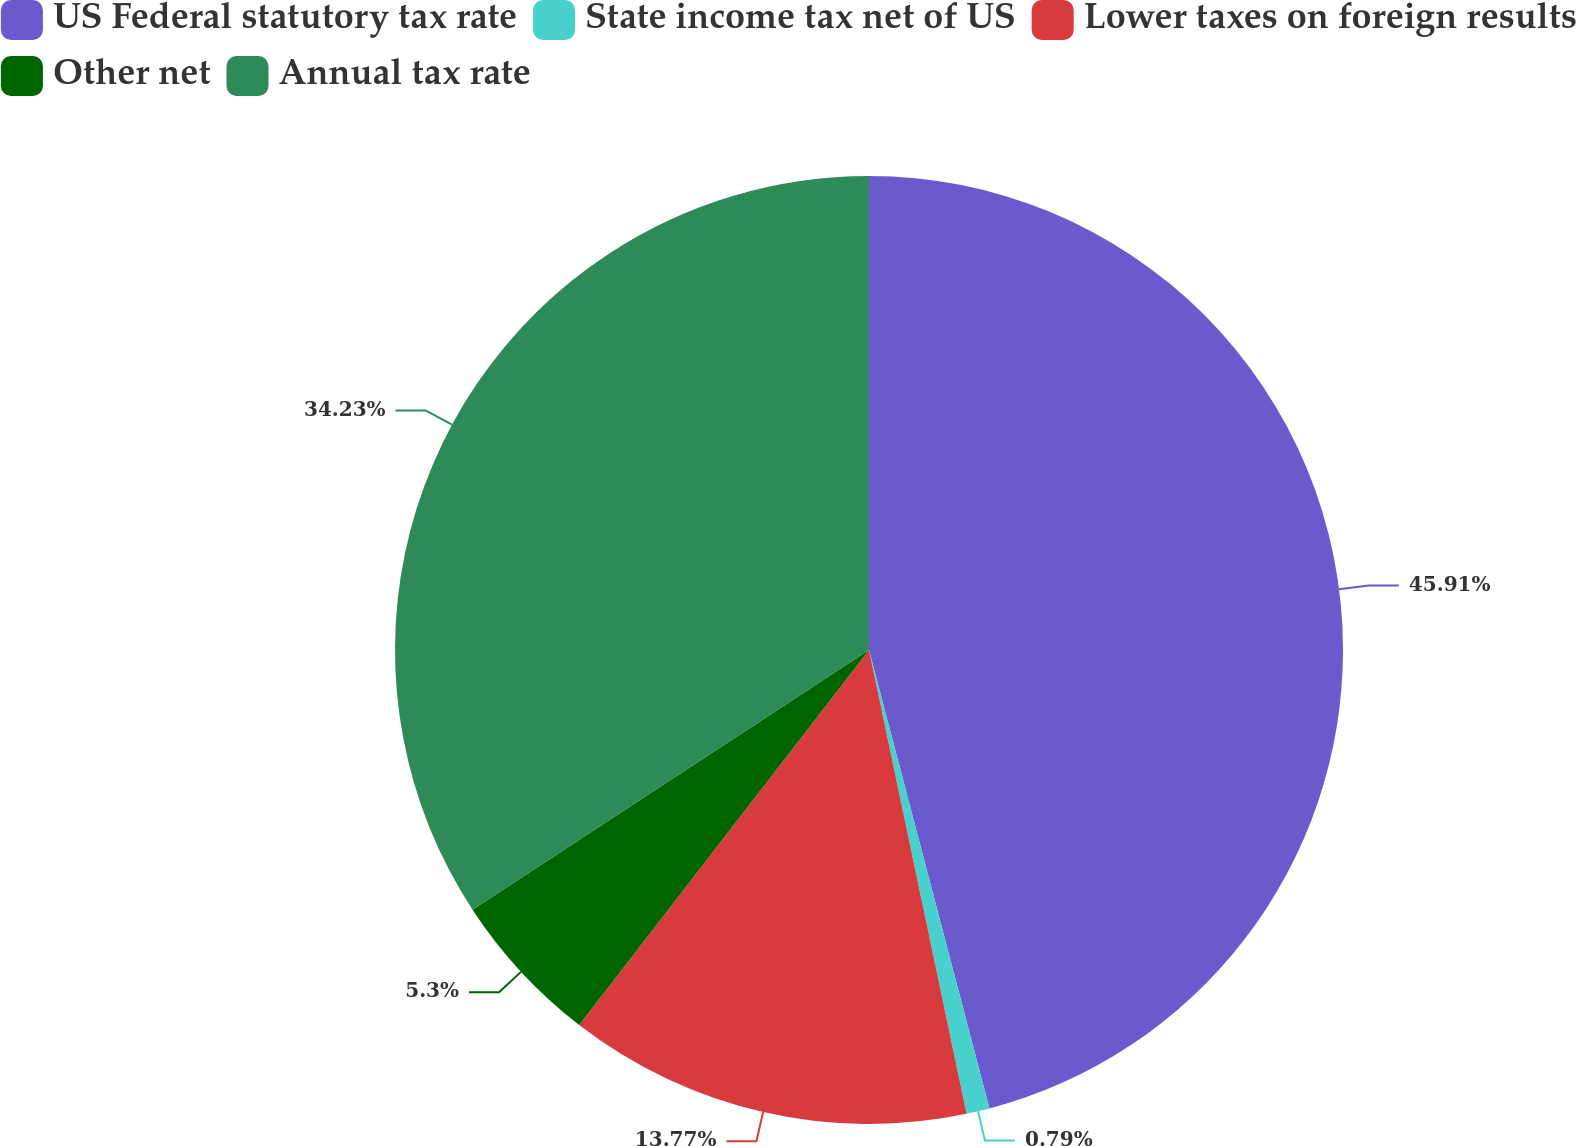Convert chart to OTSL. <chart><loc_0><loc_0><loc_500><loc_500><pie_chart><fcel>US Federal statutory tax rate<fcel>State income tax net of US<fcel>Lower taxes on foreign results<fcel>Other net<fcel>Annual tax rate<nl><fcel>45.91%<fcel>0.79%<fcel>13.77%<fcel>5.3%<fcel>34.23%<nl></chart> 